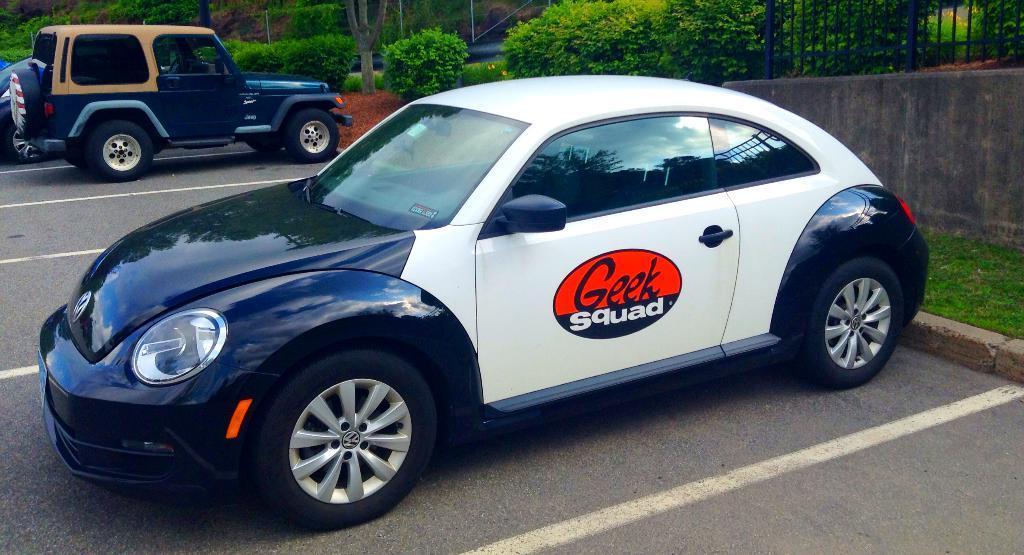How would you summarize this image in a sentence or two? In this image I can see there are few cars parked in the parking space and there are a few plants and trees in the backdrop. 